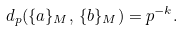Convert formula to latex. <formula><loc_0><loc_0><loc_500><loc_500>d _ { p } ( \{ a \} _ { M } , \, \{ b \} _ { M } ) = p ^ { - k } .</formula> 